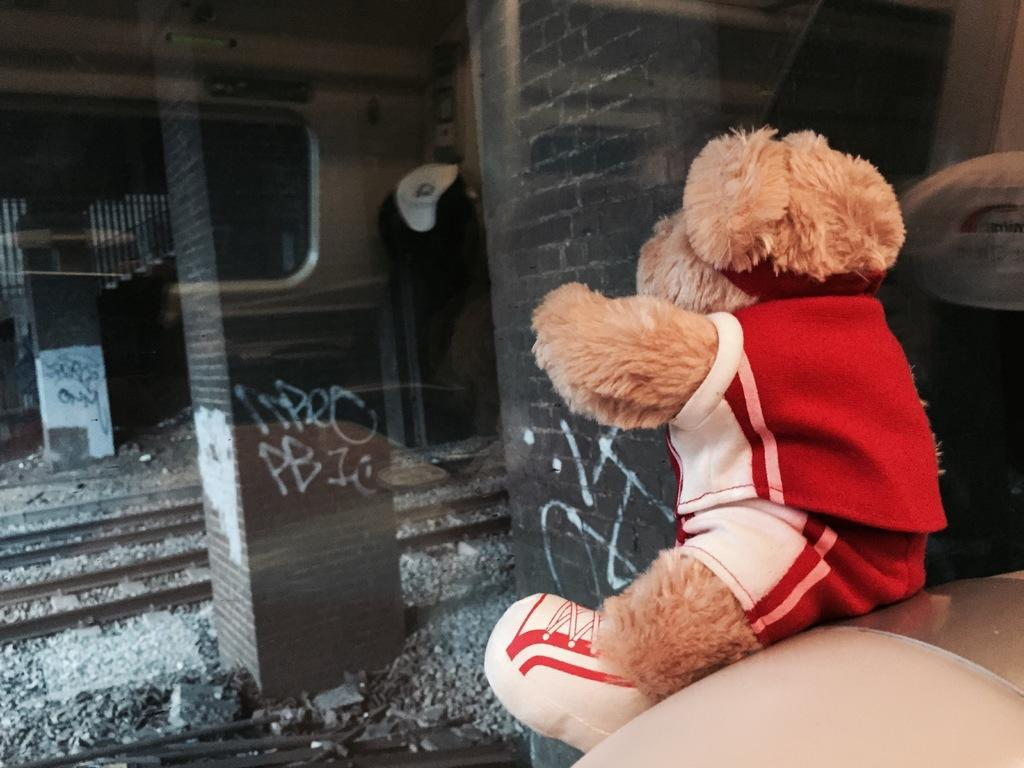What is the main subject of the image? There is a building under construction in the image. What can be seen inside the building under construction? There is a staircase in the image. What safety feature is present in the image? Railings are present in the image. What material is visible in the image? Stones are visible in the image. What unrelated item can be seen in the image? There is a soft toy in the image. What type of soda is being served at the construction site in the image? There is no soda present in the image; it features a building under construction with various objects and features. What type of produce can be seen growing near the construction site in the image? There is no produce visible in the image; it focuses on the building under construction and its surroundings. 